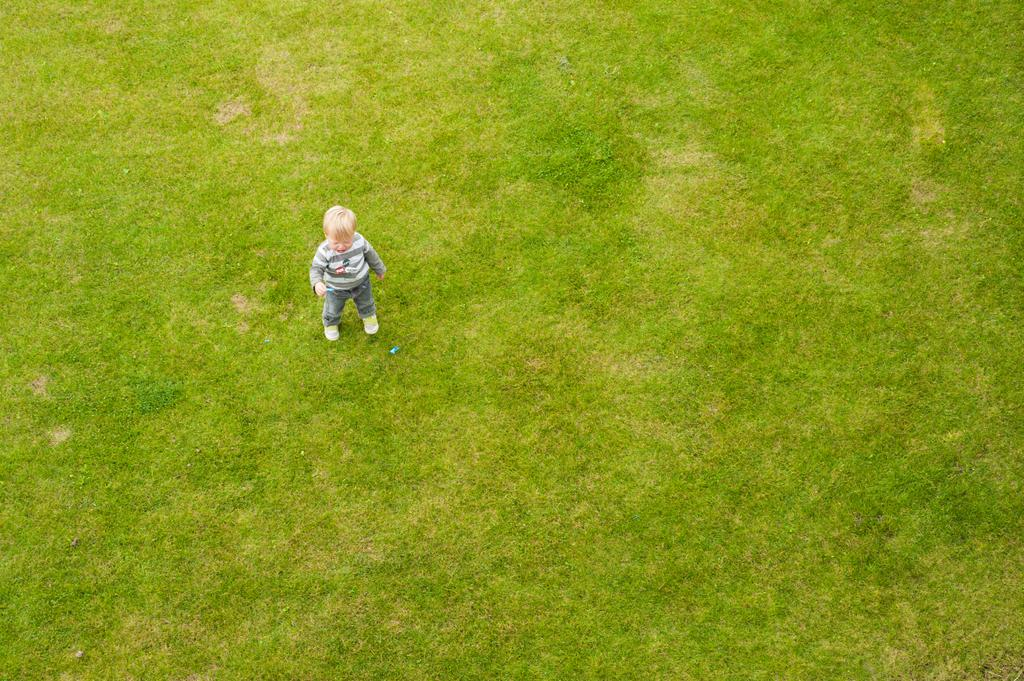What is: What is the main subject of the image? The main subject of the image is a kid. Where is the kid located in the image? The kid is standing on the grass. What type of cactus can be seen in the background of the image? There is no cactus present in the image; it features a kid standing on the grass. Is the kid holding an umbrella in the image? There is no umbrella visible in the image. 